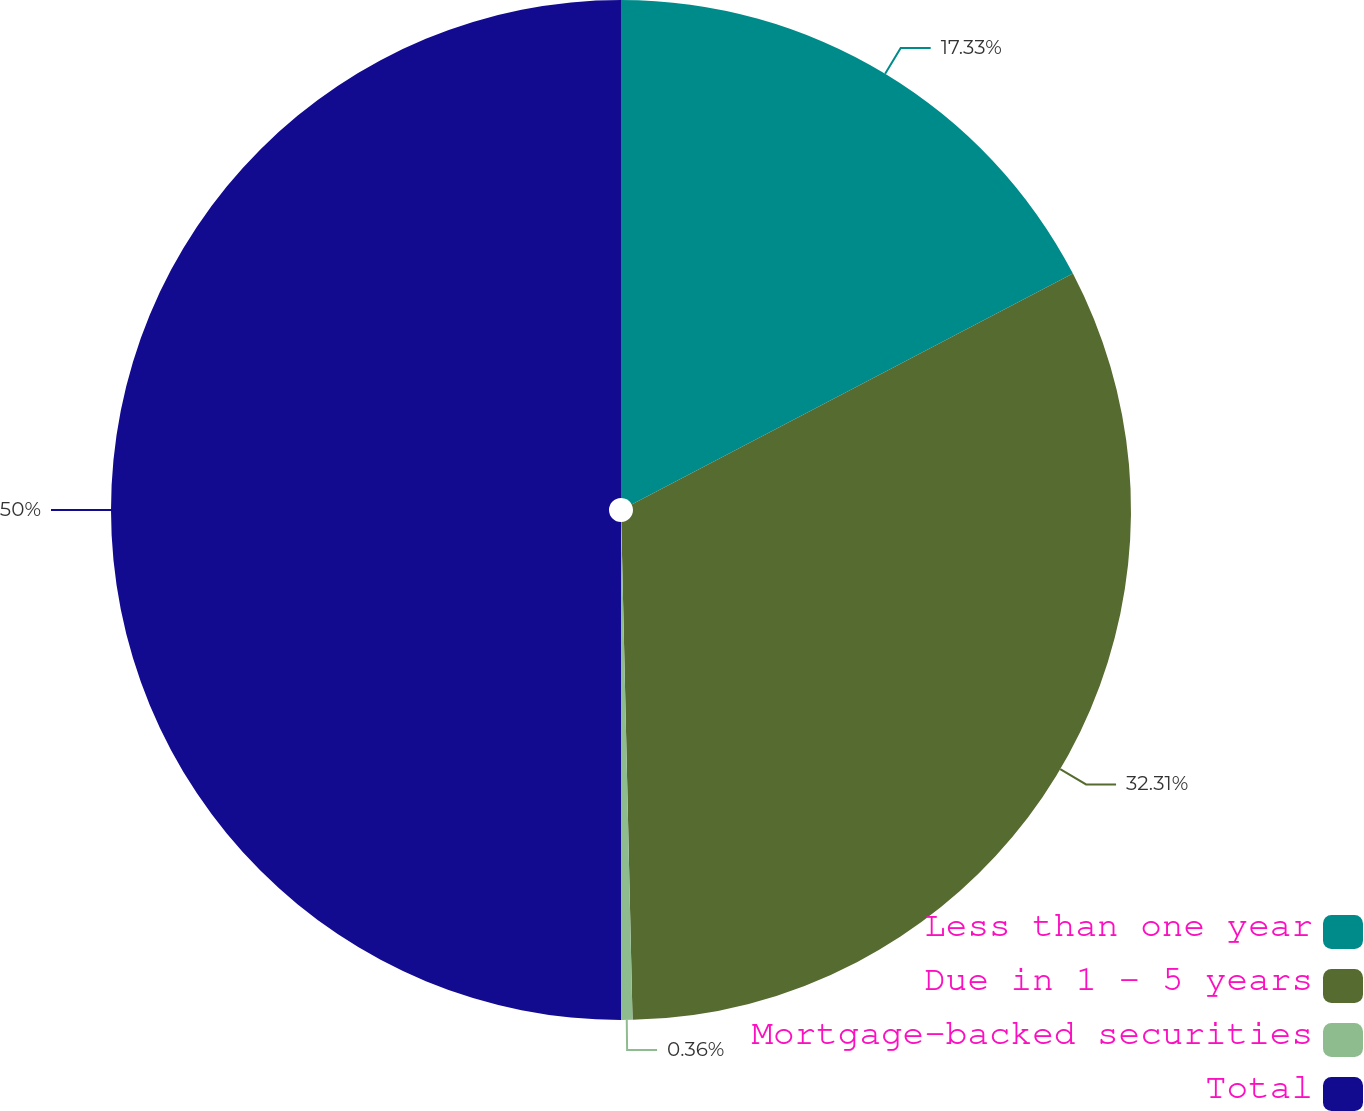Convert chart. <chart><loc_0><loc_0><loc_500><loc_500><pie_chart><fcel>Less than one year<fcel>Due in 1 - 5 years<fcel>Mortgage-backed securities<fcel>Total<nl><fcel>17.33%<fcel>32.31%<fcel>0.36%<fcel>50.0%<nl></chart> 